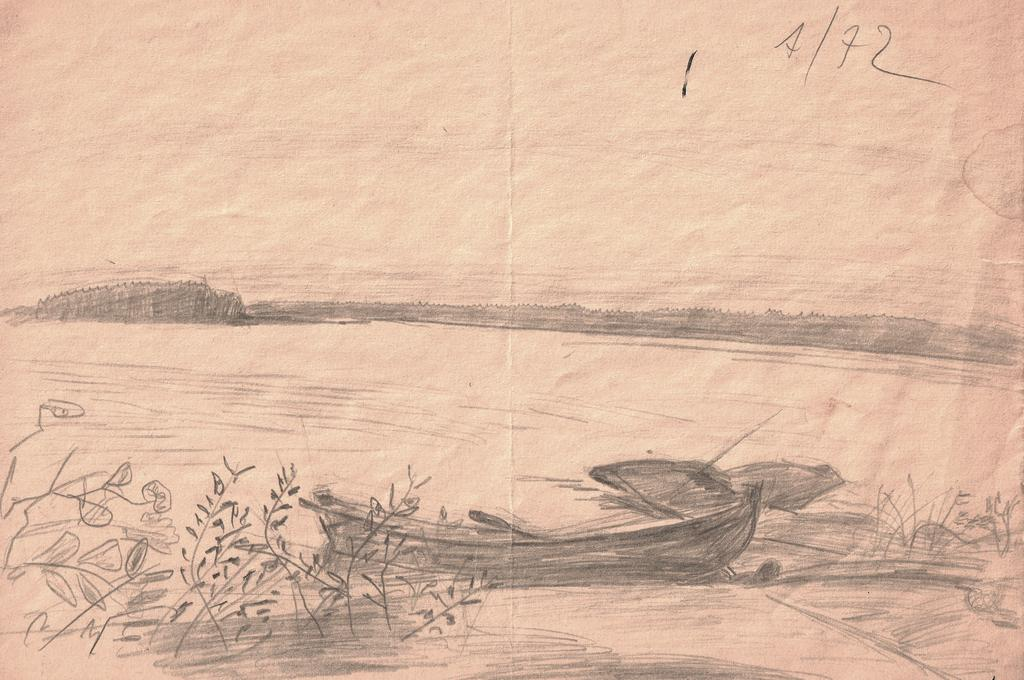What is on the paper in the image? There is water on the paper in the image. What is in the water on the paper? There is a boat and plants in the water in the image. What text is written on the paper? The text "A/72" is written on the paper in the image. How many people in the group regret eating the cracker in the image? There are no people or crackers present in the image. 